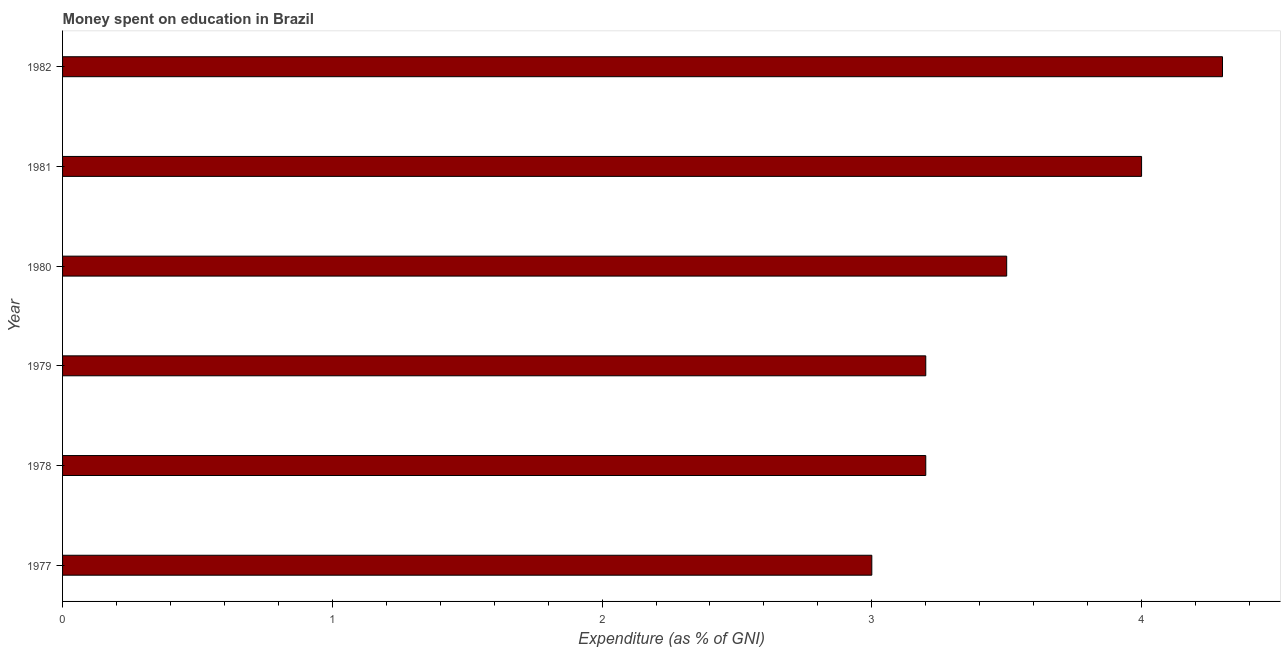Does the graph contain grids?
Provide a succinct answer. No. What is the title of the graph?
Ensure brevity in your answer.  Money spent on education in Brazil. What is the label or title of the X-axis?
Provide a short and direct response. Expenditure (as % of GNI). What is the expenditure on education in 1982?
Provide a short and direct response. 4.3. Across all years, what is the maximum expenditure on education?
Keep it short and to the point. 4.3. In which year was the expenditure on education maximum?
Give a very brief answer. 1982. What is the sum of the expenditure on education?
Ensure brevity in your answer.  21.2. What is the difference between the expenditure on education in 1977 and 1979?
Ensure brevity in your answer.  -0.2. What is the average expenditure on education per year?
Your answer should be very brief. 3.53. What is the median expenditure on education?
Your answer should be compact. 3.35. Is the difference between the expenditure on education in 1978 and 1980 greater than the difference between any two years?
Your answer should be very brief. No. Is the sum of the expenditure on education in 1978 and 1980 greater than the maximum expenditure on education across all years?
Ensure brevity in your answer.  Yes. What is the difference between the highest and the lowest expenditure on education?
Make the answer very short. 1.3. Are all the bars in the graph horizontal?
Provide a succinct answer. Yes. Are the values on the major ticks of X-axis written in scientific E-notation?
Make the answer very short. No. What is the Expenditure (as % of GNI) in 1978?
Your answer should be compact. 3.2. What is the Expenditure (as % of GNI) of 1980?
Offer a terse response. 3.5. What is the Expenditure (as % of GNI) of 1981?
Give a very brief answer. 4. What is the Expenditure (as % of GNI) of 1982?
Offer a very short reply. 4.3. What is the difference between the Expenditure (as % of GNI) in 1977 and 1979?
Your answer should be very brief. -0.2. What is the difference between the Expenditure (as % of GNI) in 1977 and 1980?
Make the answer very short. -0.5. What is the difference between the Expenditure (as % of GNI) in 1978 and 1982?
Your answer should be very brief. -1.1. What is the difference between the Expenditure (as % of GNI) in 1979 and 1981?
Offer a very short reply. -0.8. What is the difference between the Expenditure (as % of GNI) in 1980 and 1981?
Make the answer very short. -0.5. What is the difference between the Expenditure (as % of GNI) in 1981 and 1982?
Provide a succinct answer. -0.3. What is the ratio of the Expenditure (as % of GNI) in 1977 to that in 1978?
Make the answer very short. 0.94. What is the ratio of the Expenditure (as % of GNI) in 1977 to that in 1979?
Provide a short and direct response. 0.94. What is the ratio of the Expenditure (as % of GNI) in 1977 to that in 1980?
Provide a succinct answer. 0.86. What is the ratio of the Expenditure (as % of GNI) in 1977 to that in 1982?
Your answer should be very brief. 0.7. What is the ratio of the Expenditure (as % of GNI) in 1978 to that in 1979?
Your answer should be compact. 1. What is the ratio of the Expenditure (as % of GNI) in 1978 to that in 1980?
Your answer should be very brief. 0.91. What is the ratio of the Expenditure (as % of GNI) in 1978 to that in 1982?
Offer a terse response. 0.74. What is the ratio of the Expenditure (as % of GNI) in 1979 to that in 1980?
Keep it short and to the point. 0.91. What is the ratio of the Expenditure (as % of GNI) in 1979 to that in 1982?
Your response must be concise. 0.74. What is the ratio of the Expenditure (as % of GNI) in 1980 to that in 1982?
Offer a terse response. 0.81. 